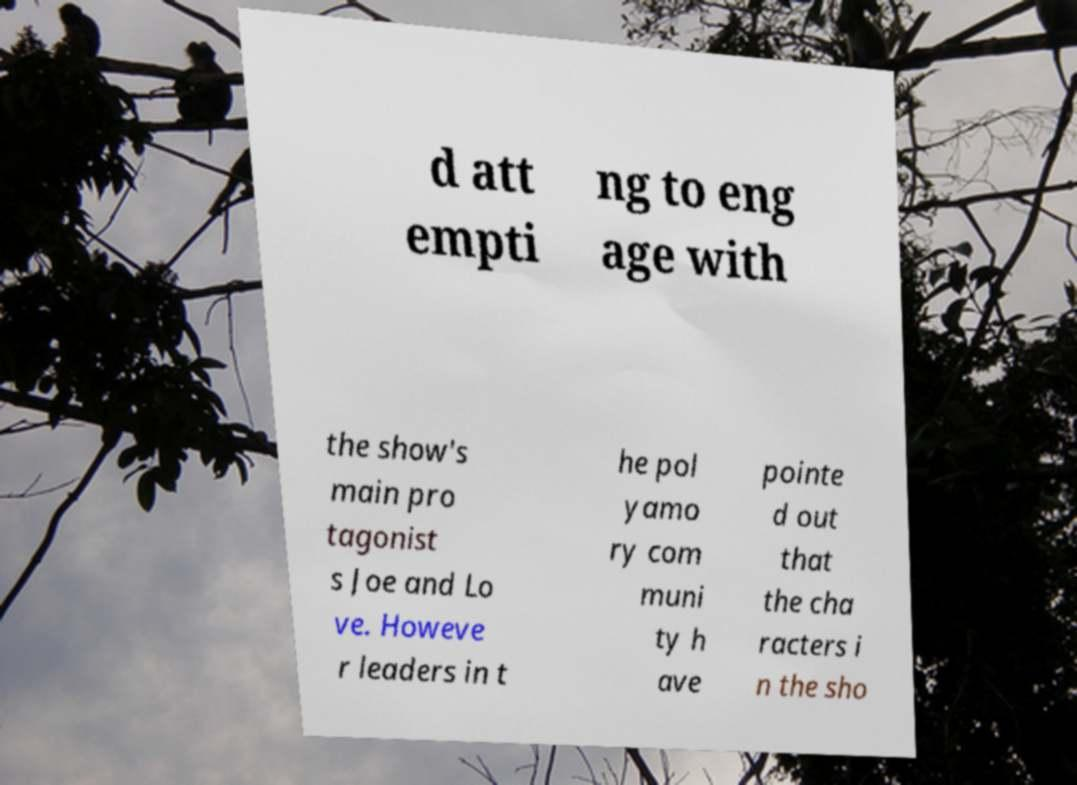There's text embedded in this image that I need extracted. Can you transcribe it verbatim? d att empti ng to eng age with the show's main pro tagonist s Joe and Lo ve. Howeve r leaders in t he pol yamo ry com muni ty h ave pointe d out that the cha racters i n the sho 